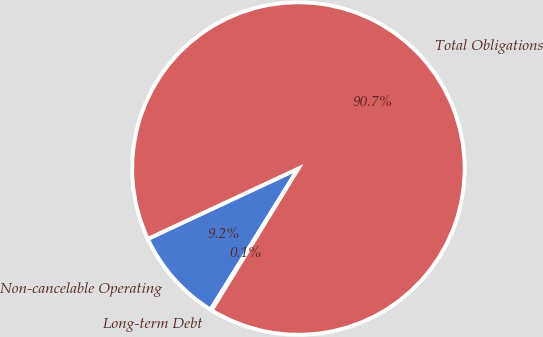Convert chart to OTSL. <chart><loc_0><loc_0><loc_500><loc_500><pie_chart><fcel>Non-cancelable Operating<fcel>Long-term Debt<fcel>Total Obligations<nl><fcel>9.18%<fcel>0.12%<fcel>90.7%<nl></chart> 